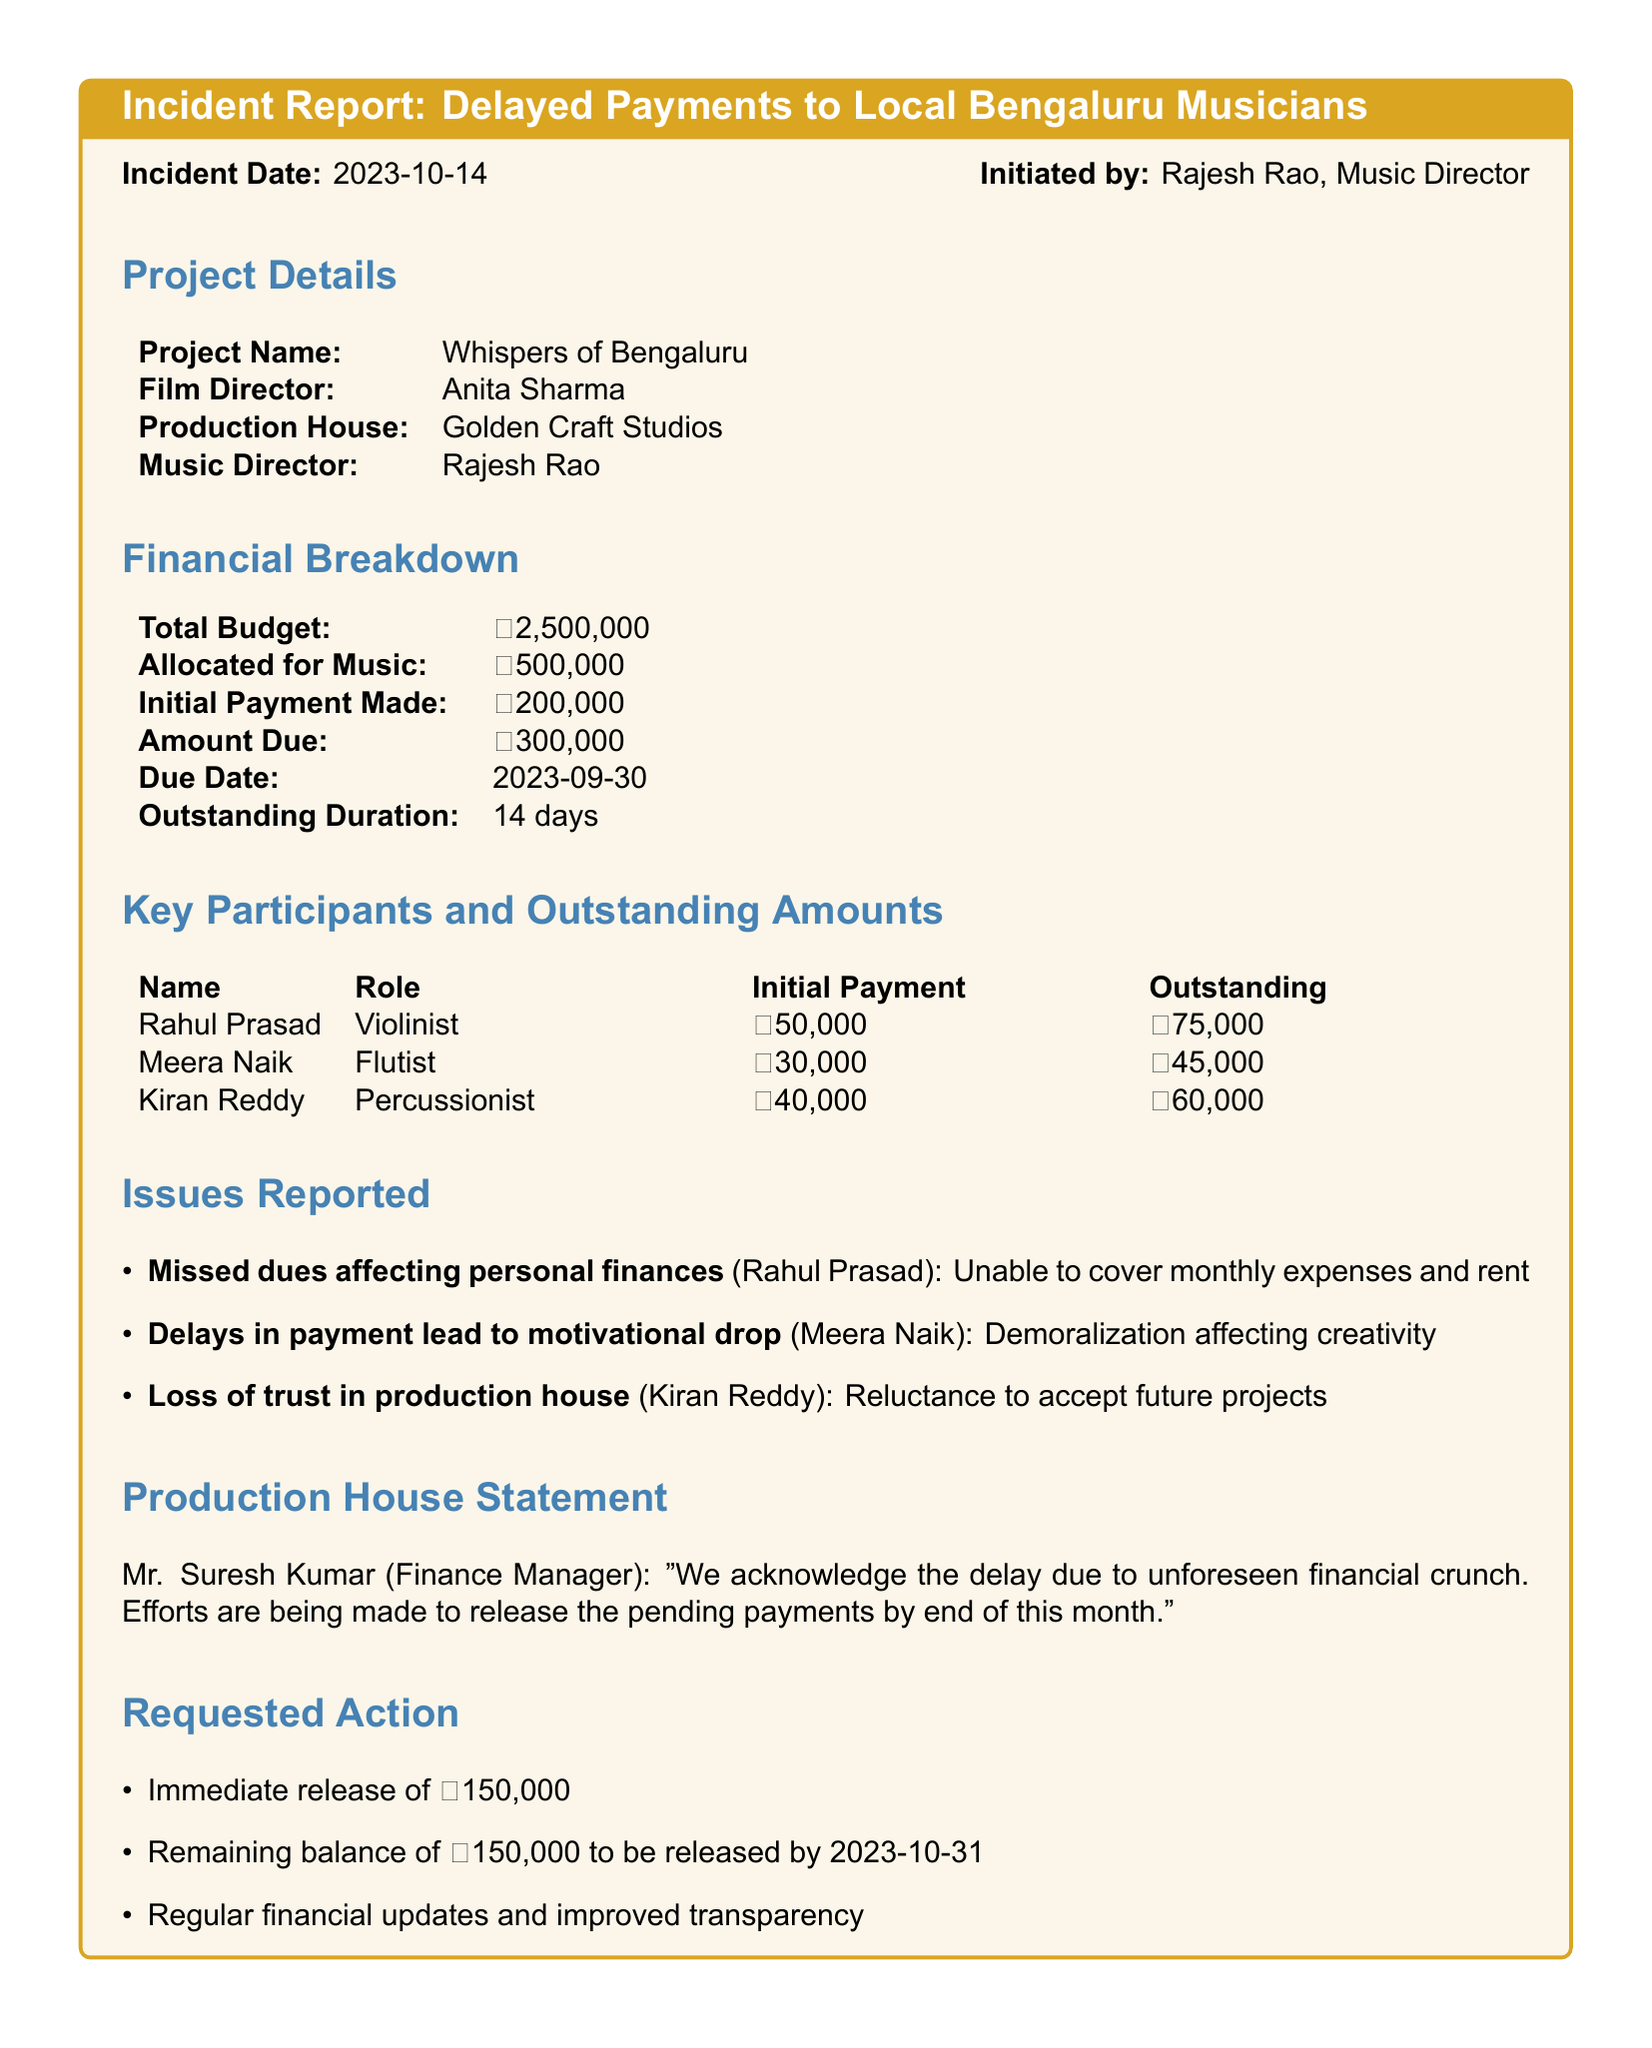What is the incident date? The incident date is provided at the beginning of the report.
Answer: 2023-10-14 Who is the music director for the project? The name of the music director is mentioned in the project details section.
Answer: Rajesh Rao What is the amount due? The section on financial breakdown states the amount due.
Answer: ₹300,000 How many days is the outstanding duration? The outstanding duration is specified in the financial breakdown section.
Answer: 14 days What is the initial payment made to Meera Naik? The initial payment for each musician is listed in the key participants section.
Answer: ₹30,000 What issue did Rahul Prasad report? The issues reported are listed under issues reported, indicating personal challenges.
Answer: Missed dues affecting personal finances What is the total budget for the project? The total budget figure is included in the financial breakdown section.
Answer: ₹2,500,000 What is the requested action regarding the remaining balance? The requested actions list specifies the timeline for releasing the balance.
Answer: By 2023-10-31 What does the finance manager state about the payment delay? The finance manager's statement addresses the reason for delays in payments.
Answer: Unforeseen financial crunch 